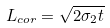Convert formula to latex. <formula><loc_0><loc_0><loc_500><loc_500>L _ { c o r } = \sqrt { 2 \sigma _ { 2 } t }</formula> 